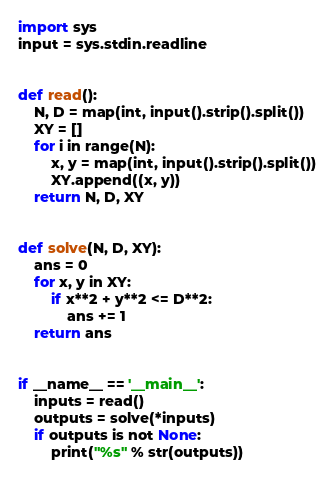Convert code to text. <code><loc_0><loc_0><loc_500><loc_500><_Python_>import sys
input = sys.stdin.readline


def read():
    N, D = map(int, input().strip().split())
    XY = []
    for i in range(N):
        x, y = map(int, input().strip().split())
        XY.append((x, y))
    return N, D, XY


def solve(N, D, XY):
    ans = 0
    for x, y in XY:
        if x**2 + y**2 <= D**2:
            ans += 1
    return ans


if __name__ == '__main__':
    inputs = read()
    outputs = solve(*inputs)
    if outputs is not None:
        print("%s" % str(outputs))
</code> 